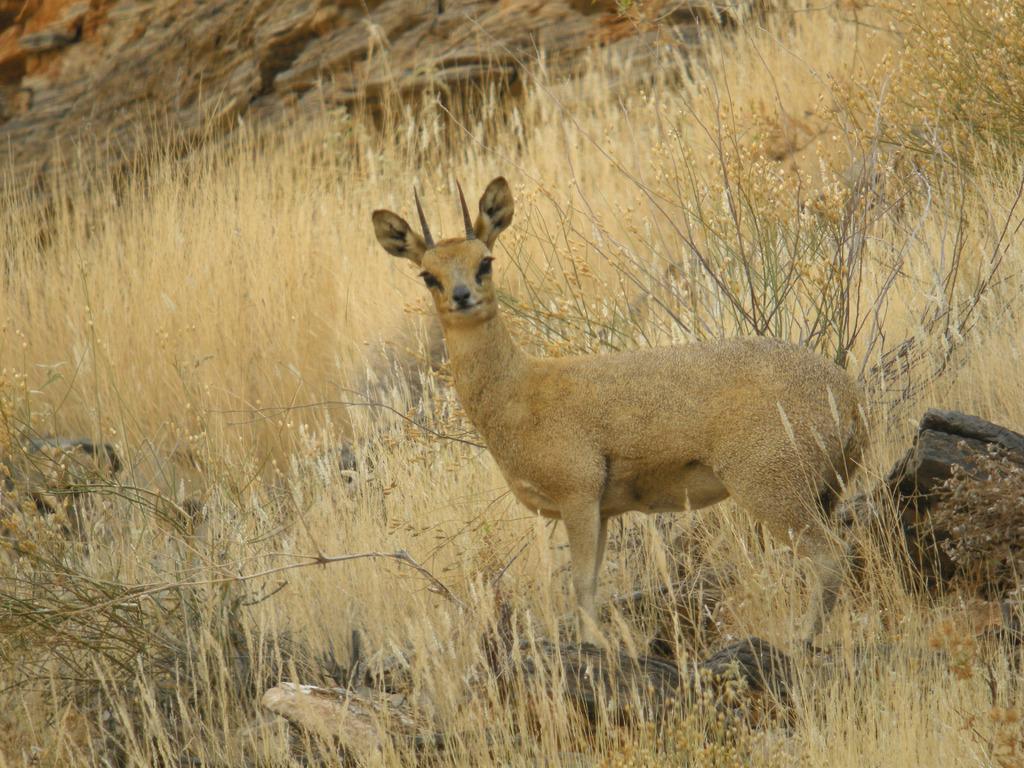How would you summarize this image in a sentence or two? This picture is clicked outside the city. In the foreground we can see the dry grass. In the center there is an animal seems to be standing on the ground. In the background we can see the rocks. 